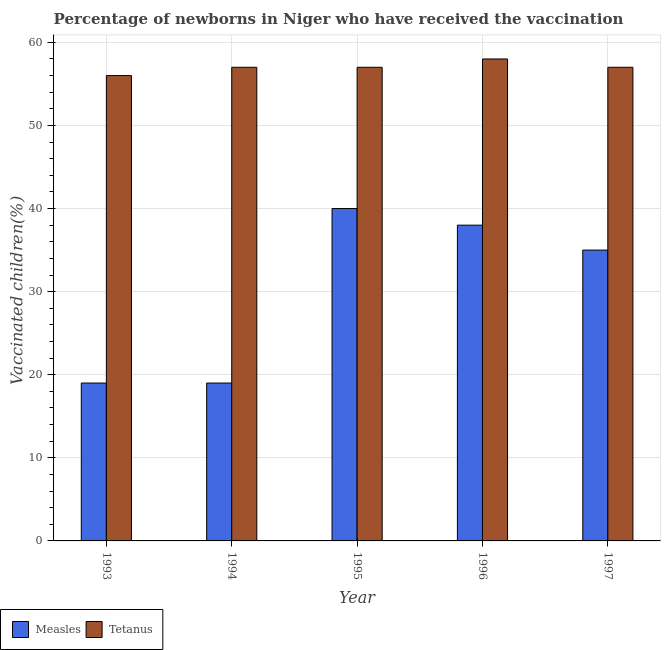In how many cases, is the number of bars for a given year not equal to the number of legend labels?
Offer a terse response. 0. What is the percentage of newborns who received vaccination for tetanus in 1997?
Your answer should be compact. 57. Across all years, what is the maximum percentage of newborns who received vaccination for tetanus?
Give a very brief answer. 58. Across all years, what is the minimum percentage of newborns who received vaccination for measles?
Offer a very short reply. 19. In which year was the percentage of newborns who received vaccination for tetanus maximum?
Provide a short and direct response. 1996. What is the total percentage of newborns who received vaccination for measles in the graph?
Offer a very short reply. 151. What is the difference between the percentage of newborns who received vaccination for tetanus in 1993 and that in 1994?
Your answer should be compact. -1. What is the difference between the percentage of newborns who received vaccination for measles in 1995 and the percentage of newborns who received vaccination for tetanus in 1993?
Offer a very short reply. 21. What is the average percentage of newborns who received vaccination for measles per year?
Make the answer very short. 30.2. In the year 1993, what is the difference between the percentage of newborns who received vaccination for tetanus and percentage of newborns who received vaccination for measles?
Ensure brevity in your answer.  0. Is the percentage of newborns who received vaccination for tetanus in 1994 less than that in 1997?
Provide a succinct answer. No. Is the difference between the percentage of newborns who received vaccination for measles in 1995 and 1996 greater than the difference between the percentage of newborns who received vaccination for tetanus in 1995 and 1996?
Provide a short and direct response. No. What is the difference between the highest and the second highest percentage of newborns who received vaccination for tetanus?
Provide a short and direct response. 1. What is the difference between the highest and the lowest percentage of newborns who received vaccination for measles?
Your response must be concise. 21. Is the sum of the percentage of newborns who received vaccination for tetanus in 1993 and 1996 greater than the maximum percentage of newborns who received vaccination for measles across all years?
Your response must be concise. Yes. What does the 1st bar from the left in 1996 represents?
Your response must be concise. Measles. What does the 2nd bar from the right in 1993 represents?
Your response must be concise. Measles. How many bars are there?
Ensure brevity in your answer.  10. Are all the bars in the graph horizontal?
Make the answer very short. No. What is the difference between two consecutive major ticks on the Y-axis?
Offer a very short reply. 10. Are the values on the major ticks of Y-axis written in scientific E-notation?
Your answer should be compact. No. Does the graph contain any zero values?
Your answer should be very brief. No. Does the graph contain grids?
Offer a terse response. Yes. Where does the legend appear in the graph?
Your answer should be compact. Bottom left. How are the legend labels stacked?
Keep it short and to the point. Horizontal. What is the title of the graph?
Your answer should be very brief. Percentage of newborns in Niger who have received the vaccination. Does "% of GNI" appear as one of the legend labels in the graph?
Make the answer very short. No. What is the label or title of the Y-axis?
Your answer should be compact. Vaccinated children(%)
. What is the Vaccinated children(%)
 of Measles in 1993?
Provide a succinct answer. 19. What is the Vaccinated children(%)
 in Tetanus in 1993?
Offer a very short reply. 56. What is the Vaccinated children(%)
 in Tetanus in 1994?
Your answer should be compact. 57. What is the Vaccinated children(%)
 of Measles in 1995?
Keep it short and to the point. 40. What is the Vaccinated children(%)
 in Measles in 1997?
Your answer should be very brief. 35. Across all years, what is the maximum Vaccinated children(%)
 of Measles?
Make the answer very short. 40. Across all years, what is the minimum Vaccinated children(%)
 in Measles?
Offer a terse response. 19. What is the total Vaccinated children(%)
 in Measles in the graph?
Ensure brevity in your answer.  151. What is the total Vaccinated children(%)
 in Tetanus in the graph?
Offer a very short reply. 285. What is the difference between the Vaccinated children(%)
 in Measles in 1993 and that in 1994?
Make the answer very short. 0. What is the difference between the Vaccinated children(%)
 of Tetanus in 1993 and that in 1994?
Your answer should be very brief. -1. What is the difference between the Vaccinated children(%)
 in Measles in 1993 and that in 1996?
Provide a succinct answer. -19. What is the difference between the Vaccinated children(%)
 of Tetanus in 1993 and that in 1996?
Your answer should be compact. -2. What is the difference between the Vaccinated children(%)
 in Measles in 1993 and that in 1997?
Provide a short and direct response. -16. What is the difference between the Vaccinated children(%)
 in Measles in 1994 and that in 1995?
Offer a terse response. -21. What is the difference between the Vaccinated children(%)
 in Tetanus in 1994 and that in 1995?
Your answer should be compact. 0. What is the difference between the Vaccinated children(%)
 of Tetanus in 1994 and that in 1997?
Offer a terse response. 0. What is the difference between the Vaccinated children(%)
 of Measles in 1995 and that in 1996?
Ensure brevity in your answer.  2. What is the difference between the Vaccinated children(%)
 of Tetanus in 1995 and that in 1996?
Your response must be concise. -1. What is the difference between the Vaccinated children(%)
 in Measles in 1995 and that in 1997?
Your response must be concise. 5. What is the difference between the Vaccinated children(%)
 in Tetanus in 1995 and that in 1997?
Your answer should be compact. 0. What is the difference between the Vaccinated children(%)
 of Tetanus in 1996 and that in 1997?
Your answer should be compact. 1. What is the difference between the Vaccinated children(%)
 of Measles in 1993 and the Vaccinated children(%)
 of Tetanus in 1994?
Your answer should be very brief. -38. What is the difference between the Vaccinated children(%)
 in Measles in 1993 and the Vaccinated children(%)
 in Tetanus in 1995?
Keep it short and to the point. -38. What is the difference between the Vaccinated children(%)
 in Measles in 1993 and the Vaccinated children(%)
 in Tetanus in 1996?
Ensure brevity in your answer.  -39. What is the difference between the Vaccinated children(%)
 of Measles in 1993 and the Vaccinated children(%)
 of Tetanus in 1997?
Offer a terse response. -38. What is the difference between the Vaccinated children(%)
 of Measles in 1994 and the Vaccinated children(%)
 of Tetanus in 1995?
Your answer should be compact. -38. What is the difference between the Vaccinated children(%)
 of Measles in 1994 and the Vaccinated children(%)
 of Tetanus in 1996?
Provide a short and direct response. -39. What is the difference between the Vaccinated children(%)
 in Measles in 1994 and the Vaccinated children(%)
 in Tetanus in 1997?
Provide a short and direct response. -38. What is the difference between the Vaccinated children(%)
 of Measles in 1995 and the Vaccinated children(%)
 of Tetanus in 1996?
Make the answer very short. -18. What is the difference between the Vaccinated children(%)
 in Measles in 1995 and the Vaccinated children(%)
 in Tetanus in 1997?
Your answer should be very brief. -17. What is the difference between the Vaccinated children(%)
 in Measles in 1996 and the Vaccinated children(%)
 in Tetanus in 1997?
Your response must be concise. -19. What is the average Vaccinated children(%)
 in Measles per year?
Your response must be concise. 30.2. In the year 1993, what is the difference between the Vaccinated children(%)
 in Measles and Vaccinated children(%)
 in Tetanus?
Provide a short and direct response. -37. In the year 1994, what is the difference between the Vaccinated children(%)
 in Measles and Vaccinated children(%)
 in Tetanus?
Your response must be concise. -38. What is the ratio of the Vaccinated children(%)
 in Measles in 1993 to that in 1994?
Your response must be concise. 1. What is the ratio of the Vaccinated children(%)
 in Tetanus in 1993 to that in 1994?
Ensure brevity in your answer.  0.98. What is the ratio of the Vaccinated children(%)
 in Measles in 1993 to that in 1995?
Give a very brief answer. 0.47. What is the ratio of the Vaccinated children(%)
 of Tetanus in 1993 to that in 1995?
Ensure brevity in your answer.  0.98. What is the ratio of the Vaccinated children(%)
 of Tetanus in 1993 to that in 1996?
Give a very brief answer. 0.97. What is the ratio of the Vaccinated children(%)
 of Measles in 1993 to that in 1997?
Provide a succinct answer. 0.54. What is the ratio of the Vaccinated children(%)
 of Tetanus in 1993 to that in 1997?
Offer a terse response. 0.98. What is the ratio of the Vaccinated children(%)
 of Measles in 1994 to that in 1995?
Ensure brevity in your answer.  0.47. What is the ratio of the Vaccinated children(%)
 of Tetanus in 1994 to that in 1995?
Your answer should be very brief. 1. What is the ratio of the Vaccinated children(%)
 in Tetanus in 1994 to that in 1996?
Provide a short and direct response. 0.98. What is the ratio of the Vaccinated children(%)
 in Measles in 1994 to that in 1997?
Provide a succinct answer. 0.54. What is the ratio of the Vaccinated children(%)
 of Tetanus in 1994 to that in 1997?
Keep it short and to the point. 1. What is the ratio of the Vaccinated children(%)
 of Measles in 1995 to that in 1996?
Your answer should be compact. 1.05. What is the ratio of the Vaccinated children(%)
 in Tetanus in 1995 to that in 1996?
Your answer should be compact. 0.98. What is the ratio of the Vaccinated children(%)
 in Tetanus in 1995 to that in 1997?
Your answer should be compact. 1. What is the ratio of the Vaccinated children(%)
 of Measles in 1996 to that in 1997?
Your response must be concise. 1.09. What is the ratio of the Vaccinated children(%)
 of Tetanus in 1996 to that in 1997?
Keep it short and to the point. 1.02. 